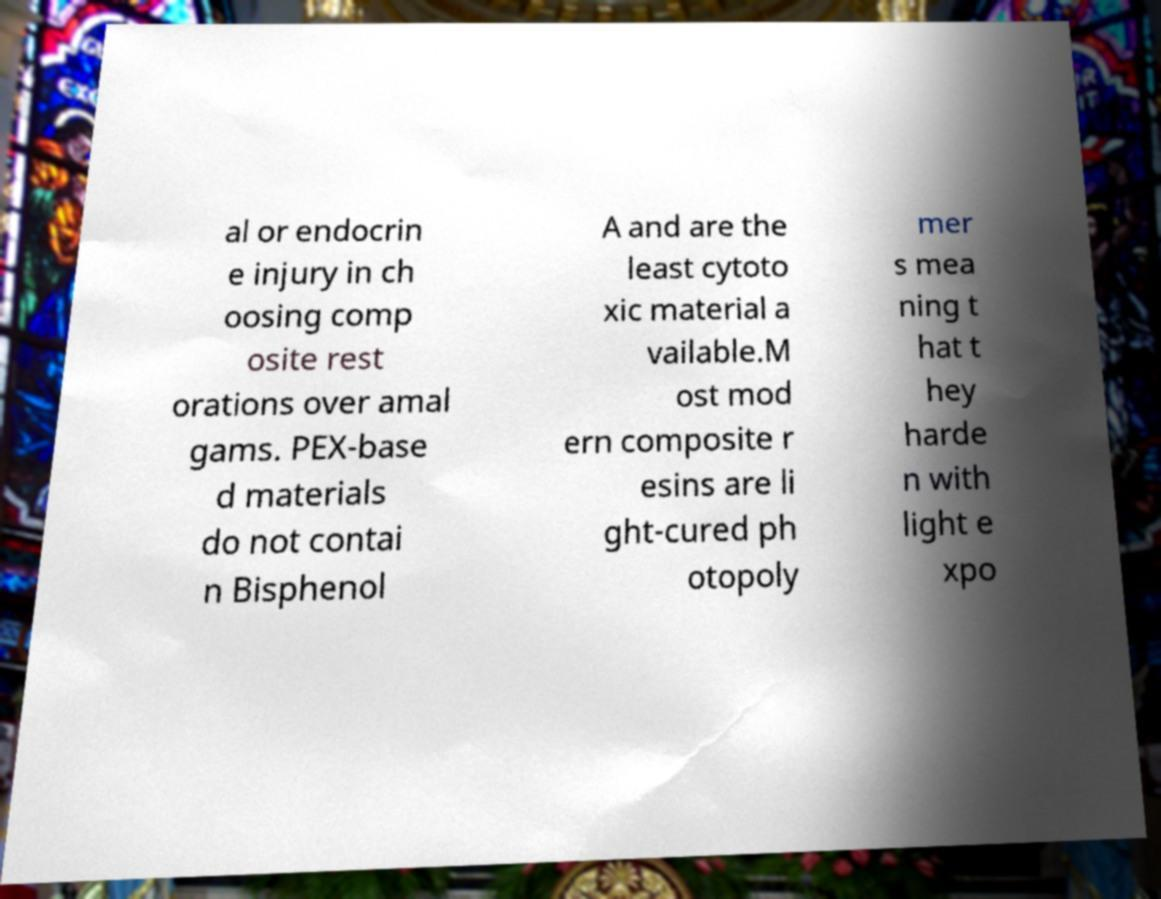Please identify and transcribe the text found in this image. al or endocrin e injury in ch oosing comp osite rest orations over amal gams. PEX-base d materials do not contai n Bisphenol A and are the least cytoto xic material a vailable.M ost mod ern composite r esins are li ght-cured ph otopoly mer s mea ning t hat t hey harde n with light e xpo 